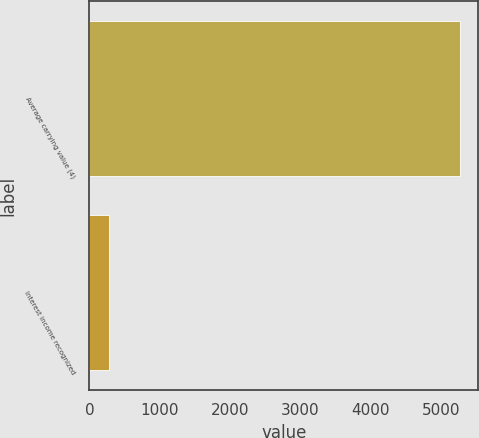<chart> <loc_0><loc_0><loc_500><loc_500><bar_chart><fcel>Average carrying value (4)<fcel>Interest income recognized<nl><fcel>5266<fcel>276<nl></chart> 